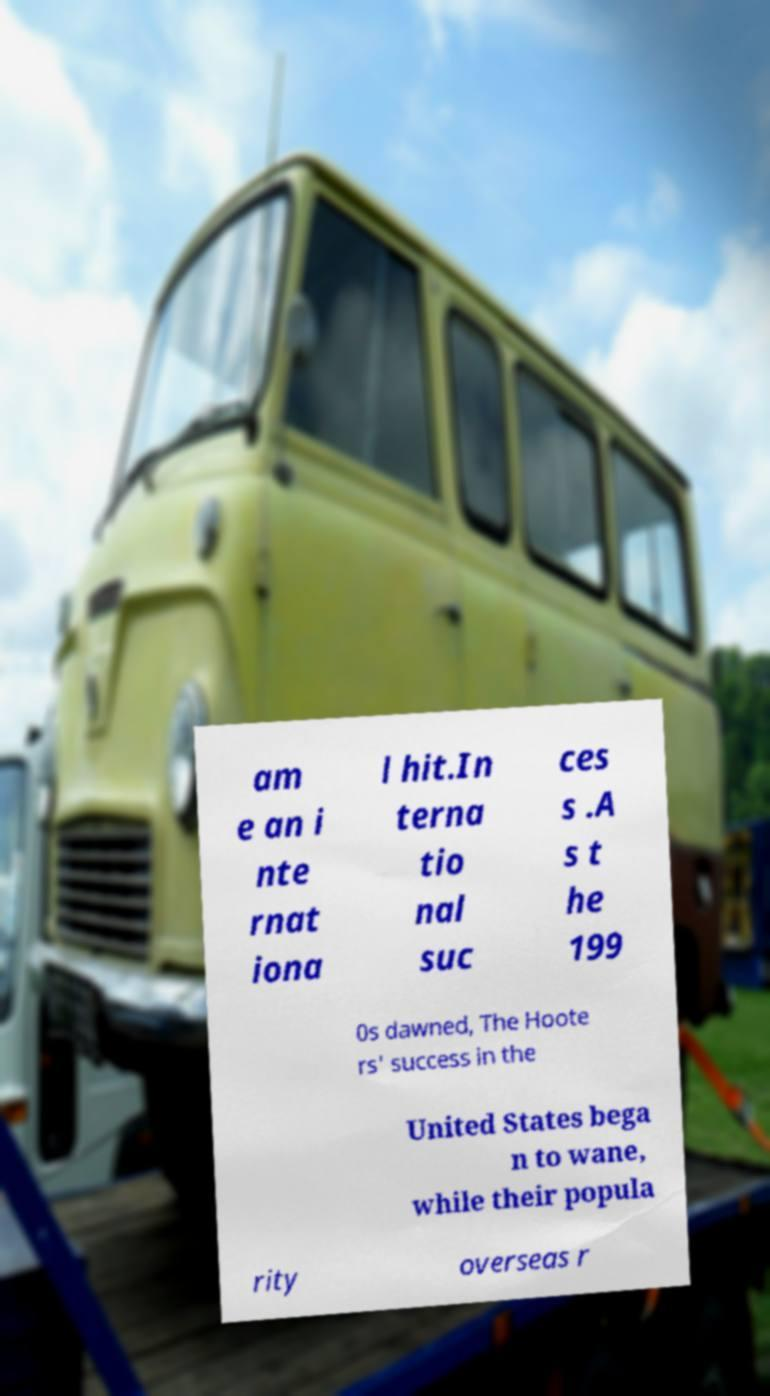For documentation purposes, I need the text within this image transcribed. Could you provide that? am e an i nte rnat iona l hit.In terna tio nal suc ces s .A s t he 199 0s dawned, The Hoote rs' success in the United States bega n to wane, while their popula rity overseas r 